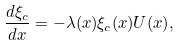<formula> <loc_0><loc_0><loc_500><loc_500>\frac { d \xi _ { c } } { d x } = - \lambda ( x ) \xi _ { c } ( x ) U ( x ) ,</formula> 